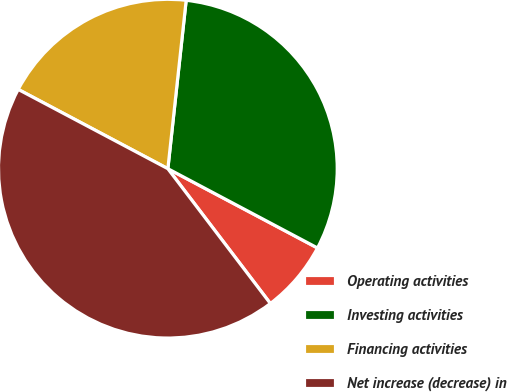Convert chart. <chart><loc_0><loc_0><loc_500><loc_500><pie_chart><fcel>Operating activities<fcel>Investing activities<fcel>Financing activities<fcel>Net increase (decrease) in<nl><fcel>6.9%<fcel>31.03%<fcel>18.97%<fcel>43.1%<nl></chart> 